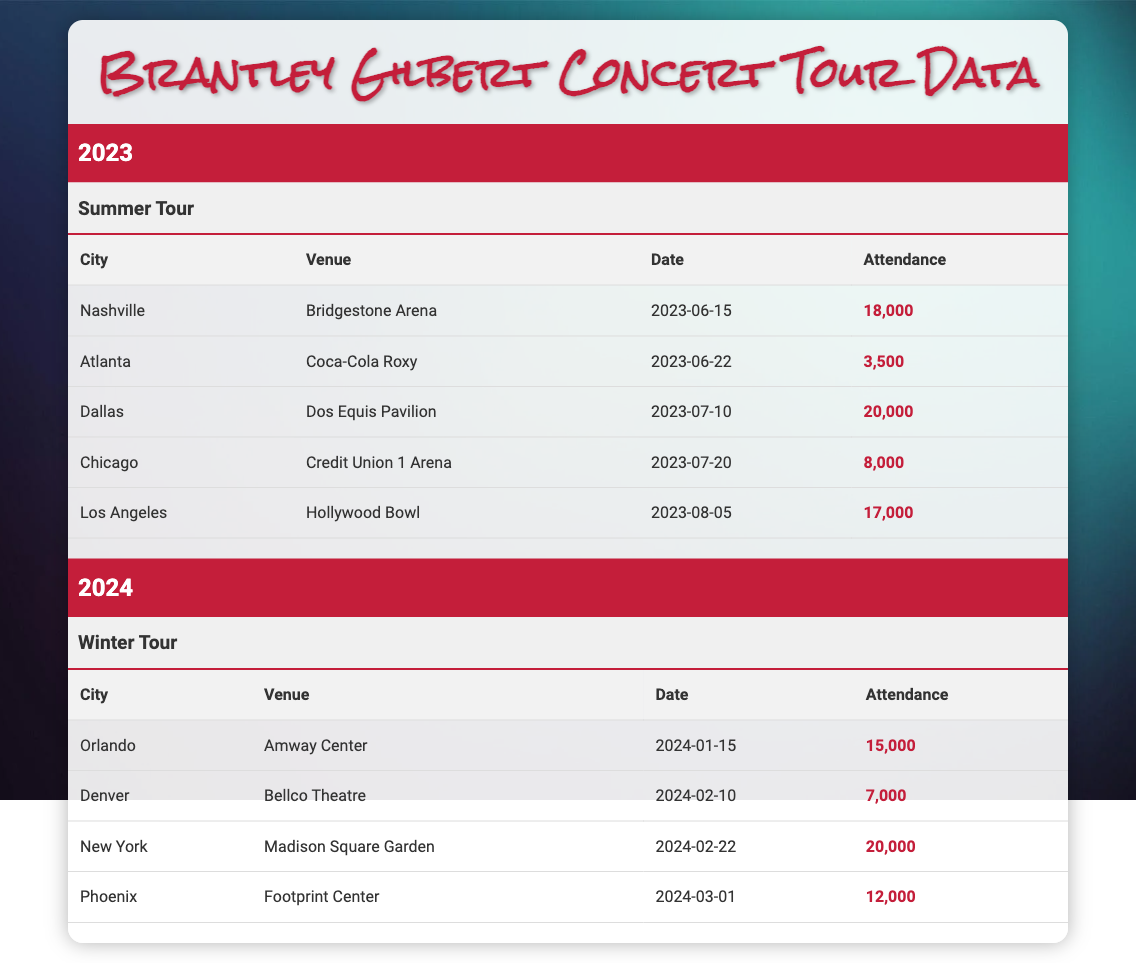What was the attendance at the Atlanta concert? The table shows that the attendance for the concert in Atlanta at the Coca-Cola Roxy on June 22, 2023, is listed as 3,500.
Answer: 3,500 Which city had the highest concert attendance in 2023? By comparing the attendance figures, Dallas had the highest concert attendance in 2023 with 20,000 attendees at the Dos Equis Pavilion on July 10.
Answer: Dallas What was the total attendance for the 2023 Summer Tour? The total attendance for the concerts in 2023 can be calculated by summing the individual attendances: 18,000 (Nashville) + 3,500 (Atlanta) + 20,000 (Dallas) + 8,000 (Chicago) + 17,000 (Los Angeles) = 66,500.
Answer: 66,500 True or False: The concert in Chicago had an attendance of more than 9,000. The attendance for the Chicago concert at Credit Union 1 Arena on July 20, 2023, is 8,000, which is less than 9,000. Therefore, the statement is false.
Answer: False What is the average attendance for the 2024 Winter Tour? To find the average attendance for the 2024 Winter Tour, add the attendance numbers: 15,000 (Orlando) + 7,000 (Denver) + 20,000 (New York) + 12,000 (Phoenix) = 54,000, and then divide by the number of concerts, which is 4. So, 54,000 / 4 = 13,500.
Answer: 13,500 Which venue had the lowest attendance in 2023? The venue with the lowest attendance in 2023 is the Coca-Cola Roxy in Atlanta, which had an attendance of 3,500 according to the attendance data.
Answer: Coca-Cola Roxy Which concert had the same attendance as the 2024 concert in Denver? The attendance at the 2024 concert in Denver at Bellco Theatre is 7,000. In the 2023 data, the concert in Atlanta also had an attendance of 3,500, while the closest match in terms of attendance is again Denver. Hence, no other concert had the same attendance as Denver in 2024.
Answer: None Was the concert in New York part of the Summer Tour? The concert in New York at Madison Square Garden on February 22, 2024, is part of the Winter Tour as indicated in the table. Therefore, the statement is false.
Answer: False 